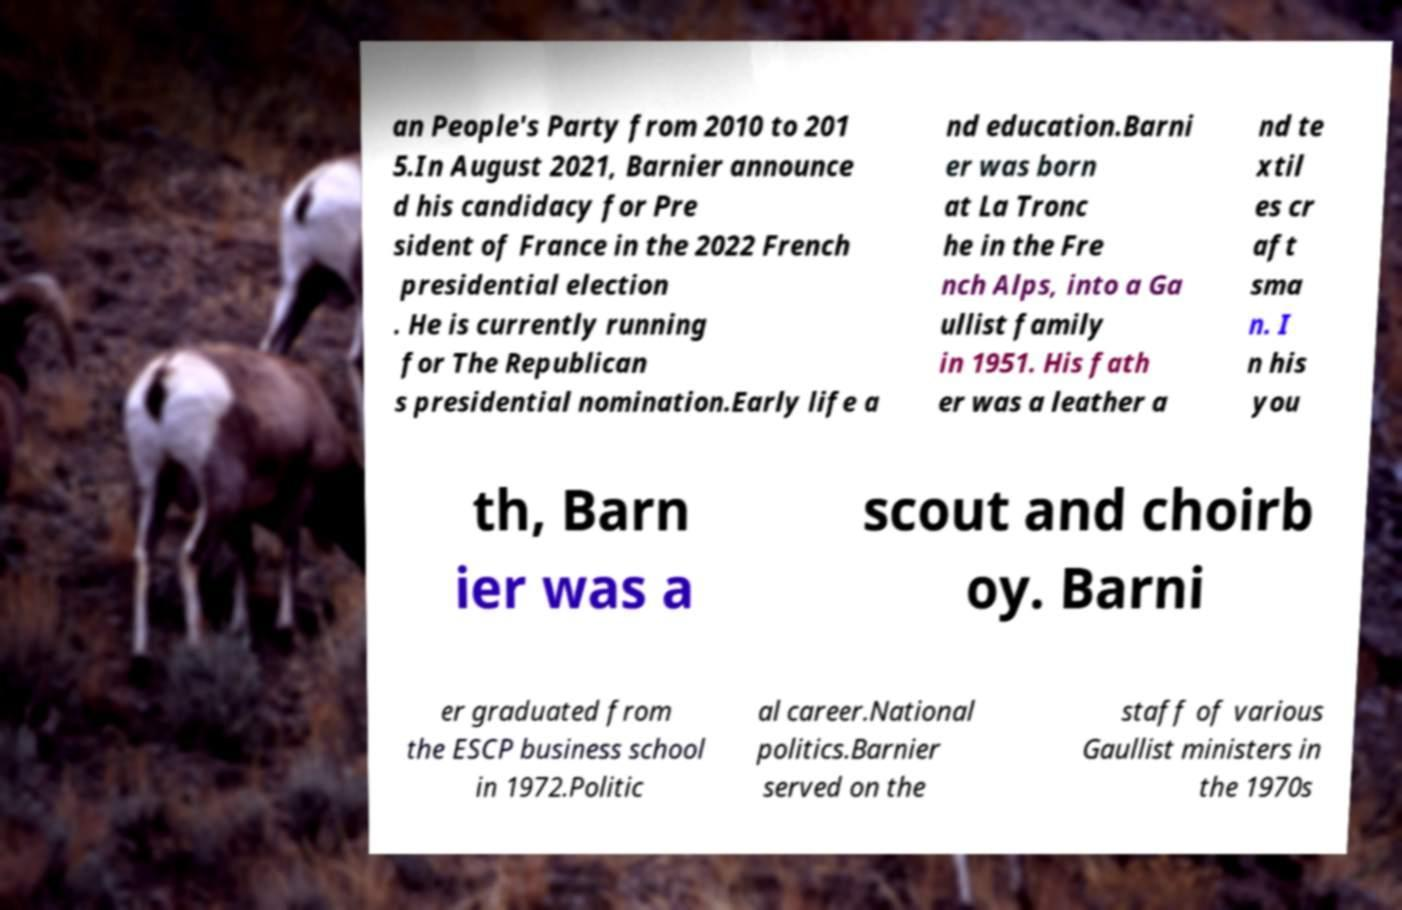Can you read and provide the text displayed in the image?This photo seems to have some interesting text. Can you extract and type it out for me? an People's Party from 2010 to 201 5.In August 2021, Barnier announce d his candidacy for Pre sident of France in the 2022 French presidential election . He is currently running for The Republican s presidential nomination.Early life a nd education.Barni er was born at La Tronc he in the Fre nch Alps, into a Ga ullist family in 1951. His fath er was a leather a nd te xtil es cr aft sma n. I n his you th, Barn ier was a scout and choirb oy. Barni er graduated from the ESCP business school in 1972.Politic al career.National politics.Barnier served on the staff of various Gaullist ministers in the 1970s 